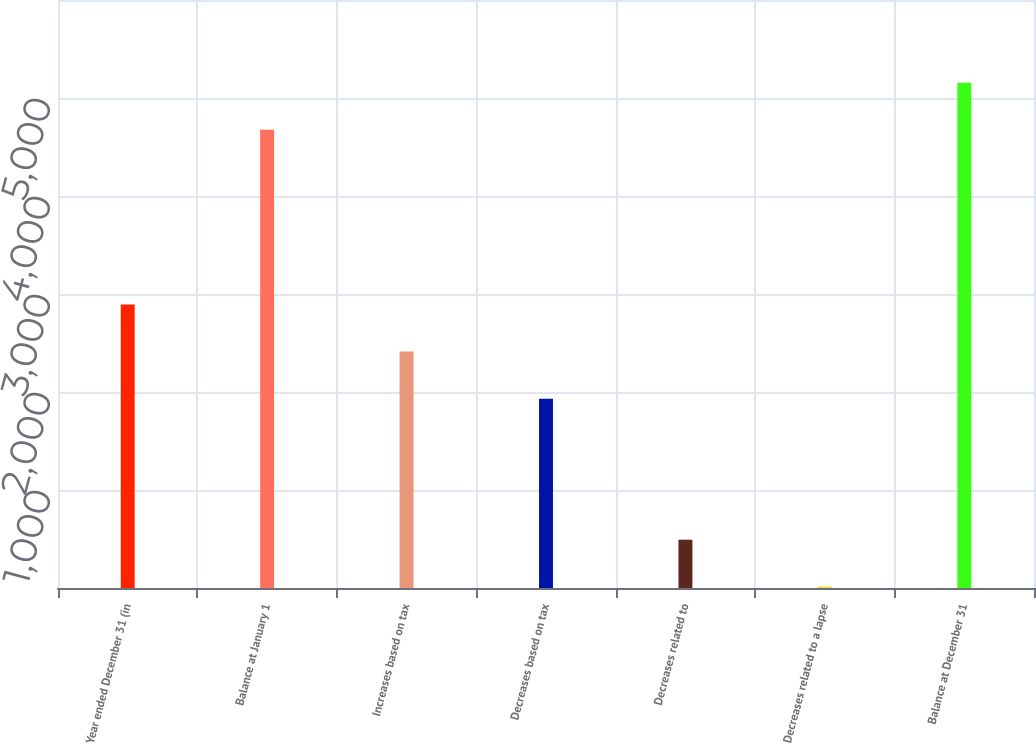<chart> <loc_0><loc_0><loc_500><loc_500><bar_chart><fcel>Year ended December 31 (in<fcel>Balance at January 1<fcel>Increases based on tax<fcel>Decreases based on tax<fcel>Decreases related to<fcel>Decreases related to a lapse<fcel>Balance at December 31<nl><fcel>2891.8<fcel>4677<fcel>2412<fcel>1932.2<fcel>492.8<fcel>13<fcel>5156.8<nl></chart> 